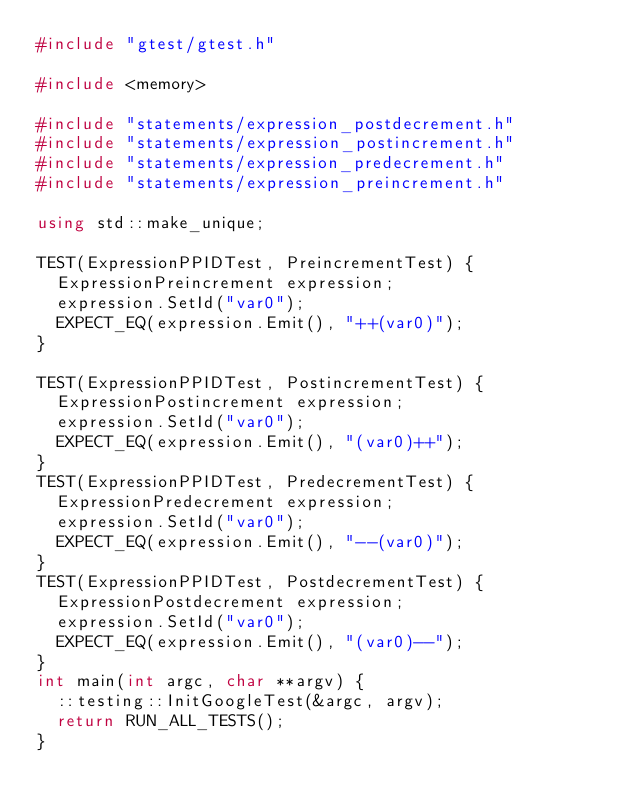<code> <loc_0><loc_0><loc_500><loc_500><_C++_>#include "gtest/gtest.h"

#include <memory>

#include "statements/expression_postdecrement.h"
#include "statements/expression_postincrement.h"
#include "statements/expression_predecrement.h"
#include "statements/expression_preincrement.h"

using std::make_unique;

TEST(ExpressionPPIDTest, PreincrementTest) {
  ExpressionPreincrement expression;
  expression.SetId("var0");
  EXPECT_EQ(expression.Emit(), "++(var0)");
}

TEST(ExpressionPPIDTest, PostincrementTest) {
  ExpressionPostincrement expression;
  expression.SetId("var0");
  EXPECT_EQ(expression.Emit(), "(var0)++");
}
TEST(ExpressionPPIDTest, PredecrementTest) {
  ExpressionPredecrement expression;
  expression.SetId("var0");
  EXPECT_EQ(expression.Emit(), "--(var0)");
}
TEST(ExpressionPPIDTest, PostdecrementTest) {
  ExpressionPostdecrement expression;
  expression.SetId("var0");
  EXPECT_EQ(expression.Emit(), "(var0)--");
}
int main(int argc, char **argv) {
  ::testing::InitGoogleTest(&argc, argv);
  return RUN_ALL_TESTS();
}
</code> 